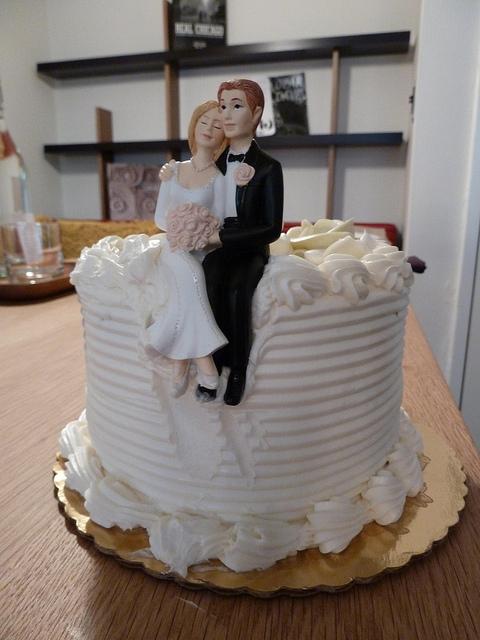Is that a real man and woman?
Concise answer only. No. How many tiers does this cake have?
Concise answer only. 1. How many tiers are there?
Answer briefly. 1. Is this a birthday cake?
Concise answer only. No. What event is this for?
Write a very short answer. Wedding. What color is the cake?
Answer briefly. White. 